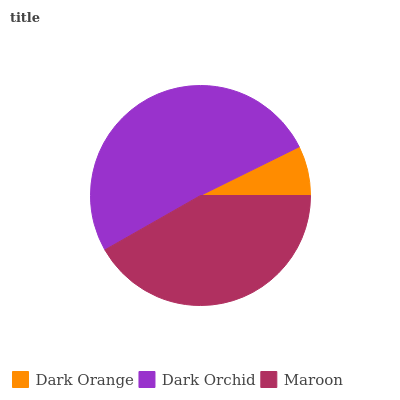Is Dark Orange the minimum?
Answer yes or no. Yes. Is Dark Orchid the maximum?
Answer yes or no. Yes. Is Maroon the minimum?
Answer yes or no. No. Is Maroon the maximum?
Answer yes or no. No. Is Dark Orchid greater than Maroon?
Answer yes or no. Yes. Is Maroon less than Dark Orchid?
Answer yes or no. Yes. Is Maroon greater than Dark Orchid?
Answer yes or no. No. Is Dark Orchid less than Maroon?
Answer yes or no. No. Is Maroon the high median?
Answer yes or no. Yes. Is Maroon the low median?
Answer yes or no. Yes. Is Dark Orange the high median?
Answer yes or no. No. Is Dark Orchid the low median?
Answer yes or no. No. 